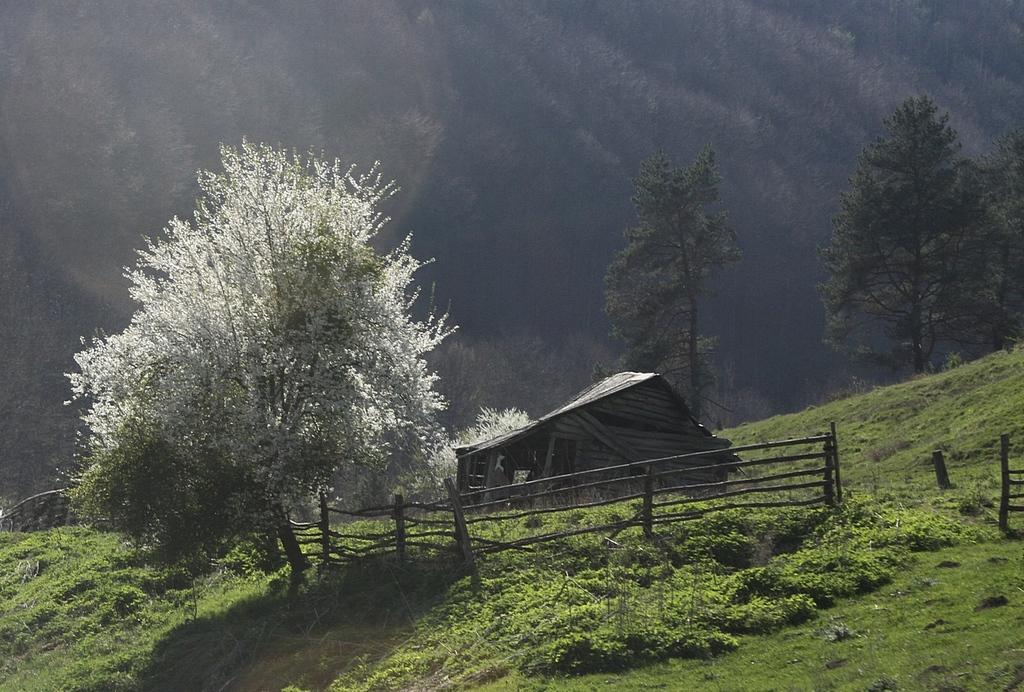What type of vegetation can be seen in the image? There are trees in the image. What is located near the tree? There is a wooden fencing near the tree. What type of structure is present in the image? There is a shed in the image. What is on the ground in the image? There are plants on the ground. How would you describe the background of the image? The background of the image is blurred. Can you see any ducks swimming in the image? There are no ducks present in the image. Is there a blade visible in the image? There is no blade present in the image. 